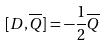Convert formula to latex. <formula><loc_0><loc_0><loc_500><loc_500>[ D , \overline { Q } ] = - \frac { 1 } { 2 } \overline { Q }</formula> 